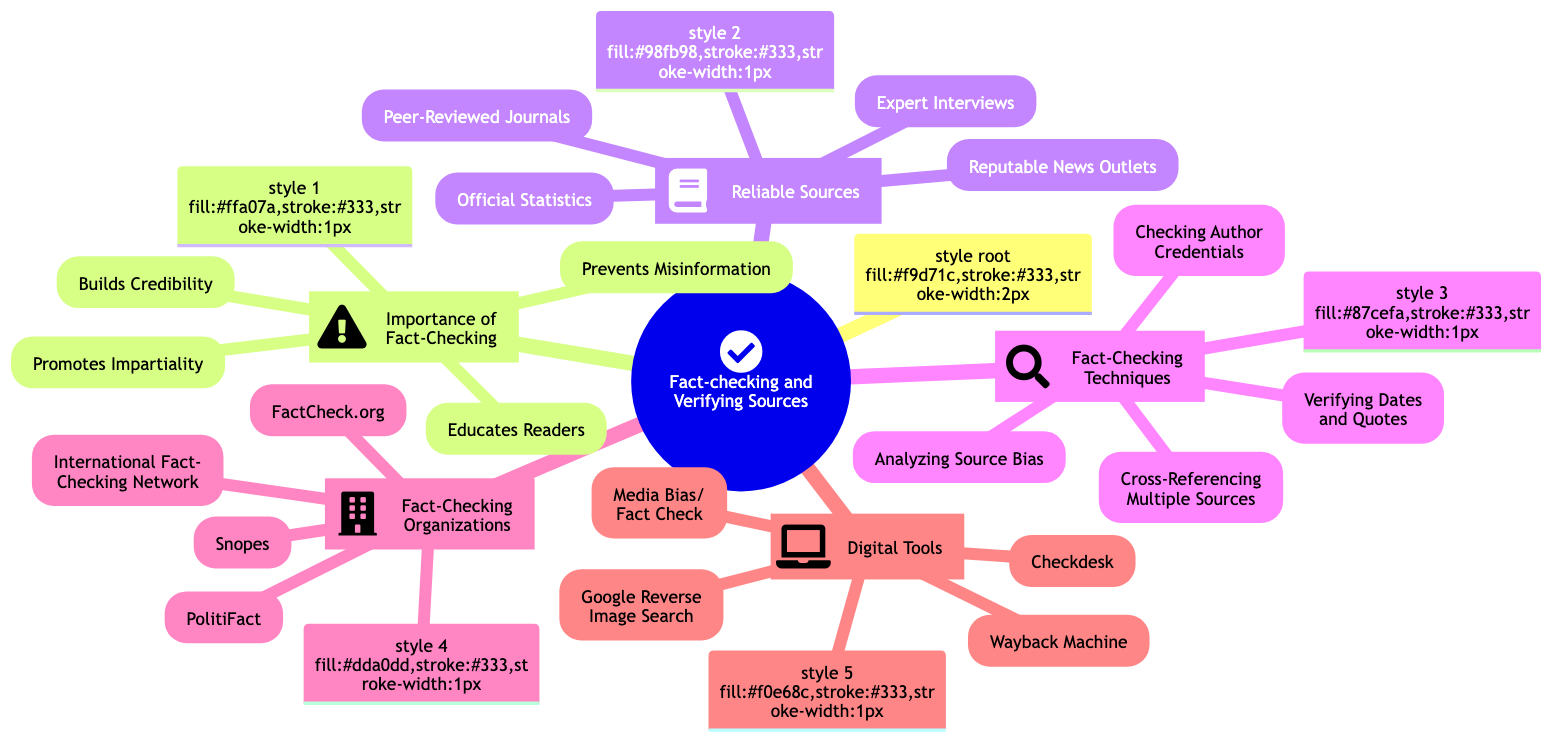What is the central topic of the diagram? The central topic is explicitly labeled at the root of the diagram as "Fact-checking and Verifying Sources".
Answer: Fact-checking and Verifying Sources How many subtopics are there in the diagram? The diagram includes a total of five subtopics branching from the central topic: Importance of Fact-Checking, Reliable Sources, Fact-Checking Techniques, Fact-Checking Organizations, and Digital Tools.
Answer: 5 Which subtopic includes the element "Peer-Reviewed Journals"? "Peer-Reviewed Journals" is listed as an element within the subtopic "Reliable Sources".
Answer: Reliable Sources What are the four elements listed under "Importance of Fact-Checking"? The elements are: Promotes Impartiality, Builds Credibility, Educates Readers, and Prevents Misinformation, all originating from the same subtopic.
Answer: Promotes Impartiality, Builds Credibility, Educates Readers, Prevents Misinformation Which fact-checking organization is listed first in the diagram? The first organization listed under the subtopic "Fact-Checking Organizations" is "Snopes".
Answer: Snopes What technique involves analyzing the bias of a source? The technique that involves analyzing the bias is "Analyzing Source Bias", which is one of the elements under the subtopic "Fact-Checking Techniques".
Answer: Analyzing Source Bias Which digital tool can be used for image verification? The digital tool used for image verification is "Google Reverse Image Search", indicated under the subtopic "Digital Tools".
Answer: Google Reverse Image Search What is the relationship between "Fact-Checking Techniques" and "Reliable Sources"? Both are subtopics that branch from the central topic, showing that they are complementary aspects of the overall theme of fact-checking and verifying information.
Answer: Complementary aspects Name one reliable source mentioned. The diagram lists "Reputable News Outlets" as one of the reliable sources under the corresponding subtopic.
Answer: Reputable News Outlets 